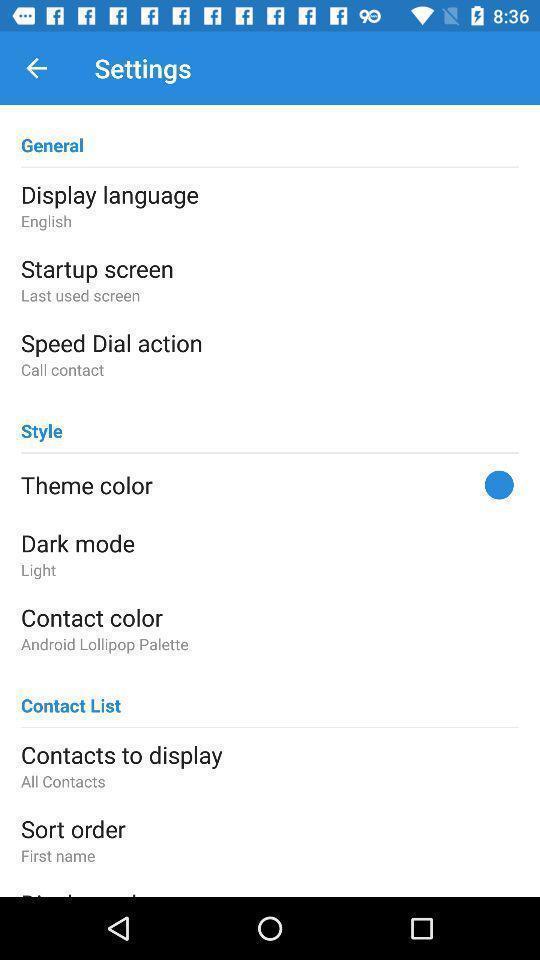Summarize the information in this screenshot. Page showing the options in settings tab. 